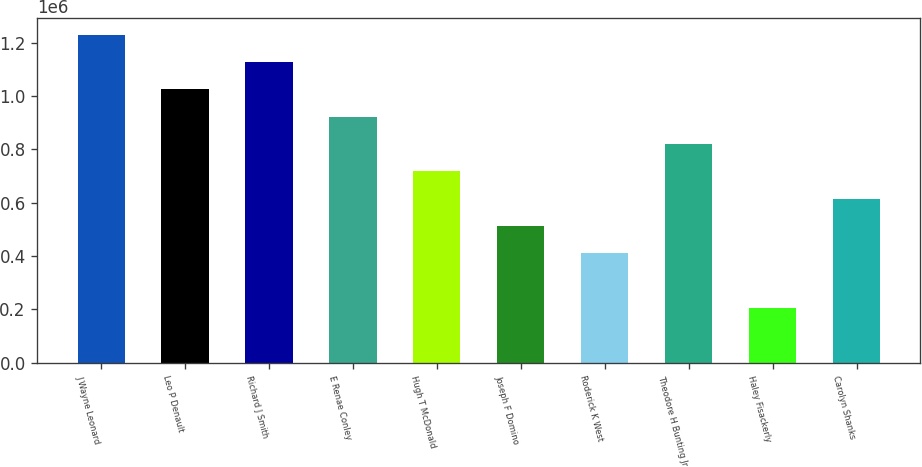Convert chart to OTSL. <chart><loc_0><loc_0><loc_500><loc_500><bar_chart><fcel>J Wayne Leonard<fcel>Leo P Denault<fcel>Richard J Smith<fcel>E Renae Conley<fcel>Hugh T McDonald<fcel>Joseph F Domino<fcel>Roderick K West<fcel>Theodore H Bunting Jr<fcel>Haley Fisackerly<fcel>Carolyn Shanks<nl><fcel>1.23e+06<fcel>1.025e+06<fcel>1.1275e+06<fcel>922501<fcel>717502<fcel>512503<fcel>410003<fcel>820002<fcel>205004<fcel>615002<nl></chart> 